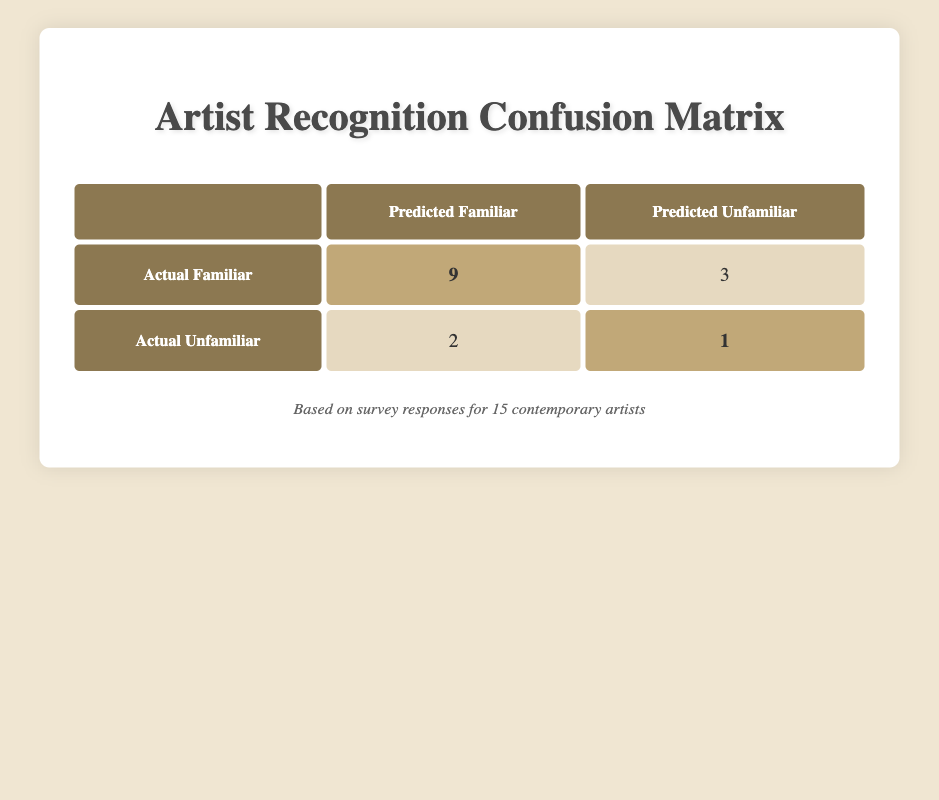What is the total number of artists in the survey? There are 9 artists classified as familiar and 3 as unfamiliar based on the table. Adding these together gives 9 + 3 = 12. However, one artist is recorded as both familiar and unfamiliar, so there are a total of 15 unique artists surveyed.
Answer: 15 How many artists were correctly predicted to be familiar? The table indicates that 9 artists were actually familiar and were predicted as familiar. This is a direct retrieval from the table under the "Predicted Familiar" column for "Actual Familiar."
Answer: 9 What is the number of artists incorrectly predicted as familiar? The table shows 3 artists who were familiar but predicted as unfamiliar, along with 2 unfamiliar artists predicted as familiar. Summing these gives 3 + 2 = 5.
Answer: 5 What percentage of familiar artists were correctly predicted? There are 9 familiar artists predicted correctly out of a total of 12 familiar artists surveyed, which gives a percentage of (9/12)*100 = 75%.
Answer: 75% How many artists were predicted to be unfamiliar but were actually familiar? The table indicates there are 3 artists who were familiar but incorrectly predicted as unfamiliar. This is retrieved directly from the table.
Answer: 3 Is it true that more unfamiliar artists were predicted correctly than familiar ones? The table indicates that 1 unfamiliar artist was correctly predicted as unfamiliar, and 9 familiar artists were correctly predicted. Therefore, the statement is false because 9 is greater than 1.
Answer: No What is the difference between the number of familiar artists and unfamiliar artists predicted as familiar? There are 2 unfamiliar artists predicted as familiar and 9 familiar artists. The difference is 9 - 2 = 7.
Answer: 7 How many total misclassifications occurred in the survey? Misclassifications can be calculated by adding the false familiar and false unfamiliar counts. There are 3 familiar artists predicted as unfamiliar and 2 unfamiliar artists predicted as familiar: 3 + 2 = 5.
Answer: 5 What is the ratio of correctly predicted familiar artists to incorrectly predicted familiar artists? The number of correctly predicted familiar artists is 9, while the incorrectly predicted familiar artists number is 5. Therefore, the ratio is 9:5.
Answer: 9:5 